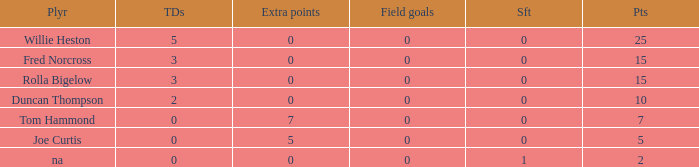How many touchdowns has a player of rolla bigelow scored, and an extra points fewer than 0? None. 